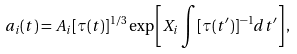<formula> <loc_0><loc_0><loc_500><loc_500>a _ { i } ( t ) = A _ { i } [ \tau ( t ) ] ^ { 1 / 3 } \exp \left [ X _ { i } \int [ \tau ( t ^ { \prime } ) ] ^ { - 1 } d t ^ { \prime } \right ] ,</formula> 